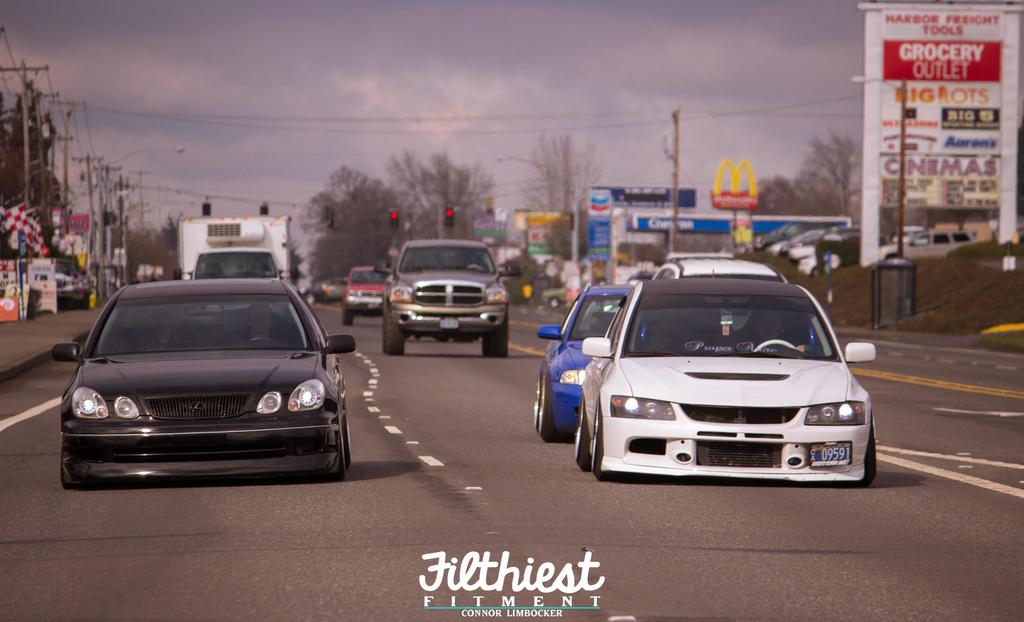What word is printed directly under the word "grocery" on the billboard on the right?
Make the answer very short. Outlet. What is written under fitment in the middle bottom of this picture?
Offer a terse response. Connor limbocker. 